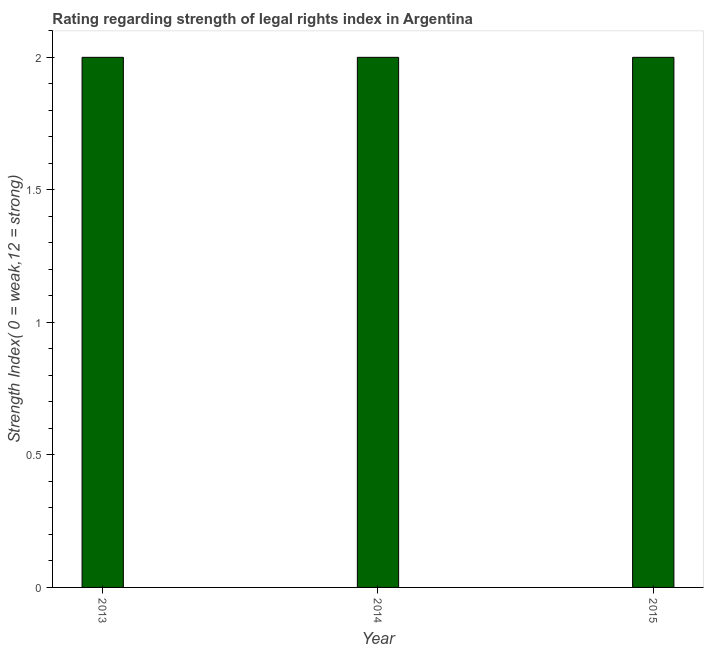What is the title of the graph?
Your answer should be compact. Rating regarding strength of legal rights index in Argentina. What is the label or title of the X-axis?
Offer a terse response. Year. What is the label or title of the Y-axis?
Offer a very short reply. Strength Index( 0 = weak,12 = strong). Across all years, what is the maximum strength of legal rights index?
Your answer should be very brief. 2. What is the average strength of legal rights index per year?
Ensure brevity in your answer.  2. In how many years, is the strength of legal rights index greater than 0.5 ?
Offer a very short reply. 3. Do a majority of the years between 2014 and 2013 (inclusive) have strength of legal rights index greater than 1.8 ?
Your answer should be very brief. No. What is the ratio of the strength of legal rights index in 2013 to that in 2015?
Offer a very short reply. 1. Is the strength of legal rights index in 2013 less than that in 2015?
Provide a short and direct response. No. What is the difference between the highest and the second highest strength of legal rights index?
Your answer should be compact. 0. In how many years, is the strength of legal rights index greater than the average strength of legal rights index taken over all years?
Your response must be concise. 0. Are all the bars in the graph horizontal?
Ensure brevity in your answer.  No. How many years are there in the graph?
Keep it short and to the point. 3. Are the values on the major ticks of Y-axis written in scientific E-notation?
Offer a very short reply. No. What is the difference between the Strength Index( 0 = weak,12 = strong) in 2014 and 2015?
Keep it short and to the point. 0. What is the ratio of the Strength Index( 0 = weak,12 = strong) in 2013 to that in 2015?
Offer a very short reply. 1. What is the ratio of the Strength Index( 0 = weak,12 = strong) in 2014 to that in 2015?
Provide a succinct answer. 1. 